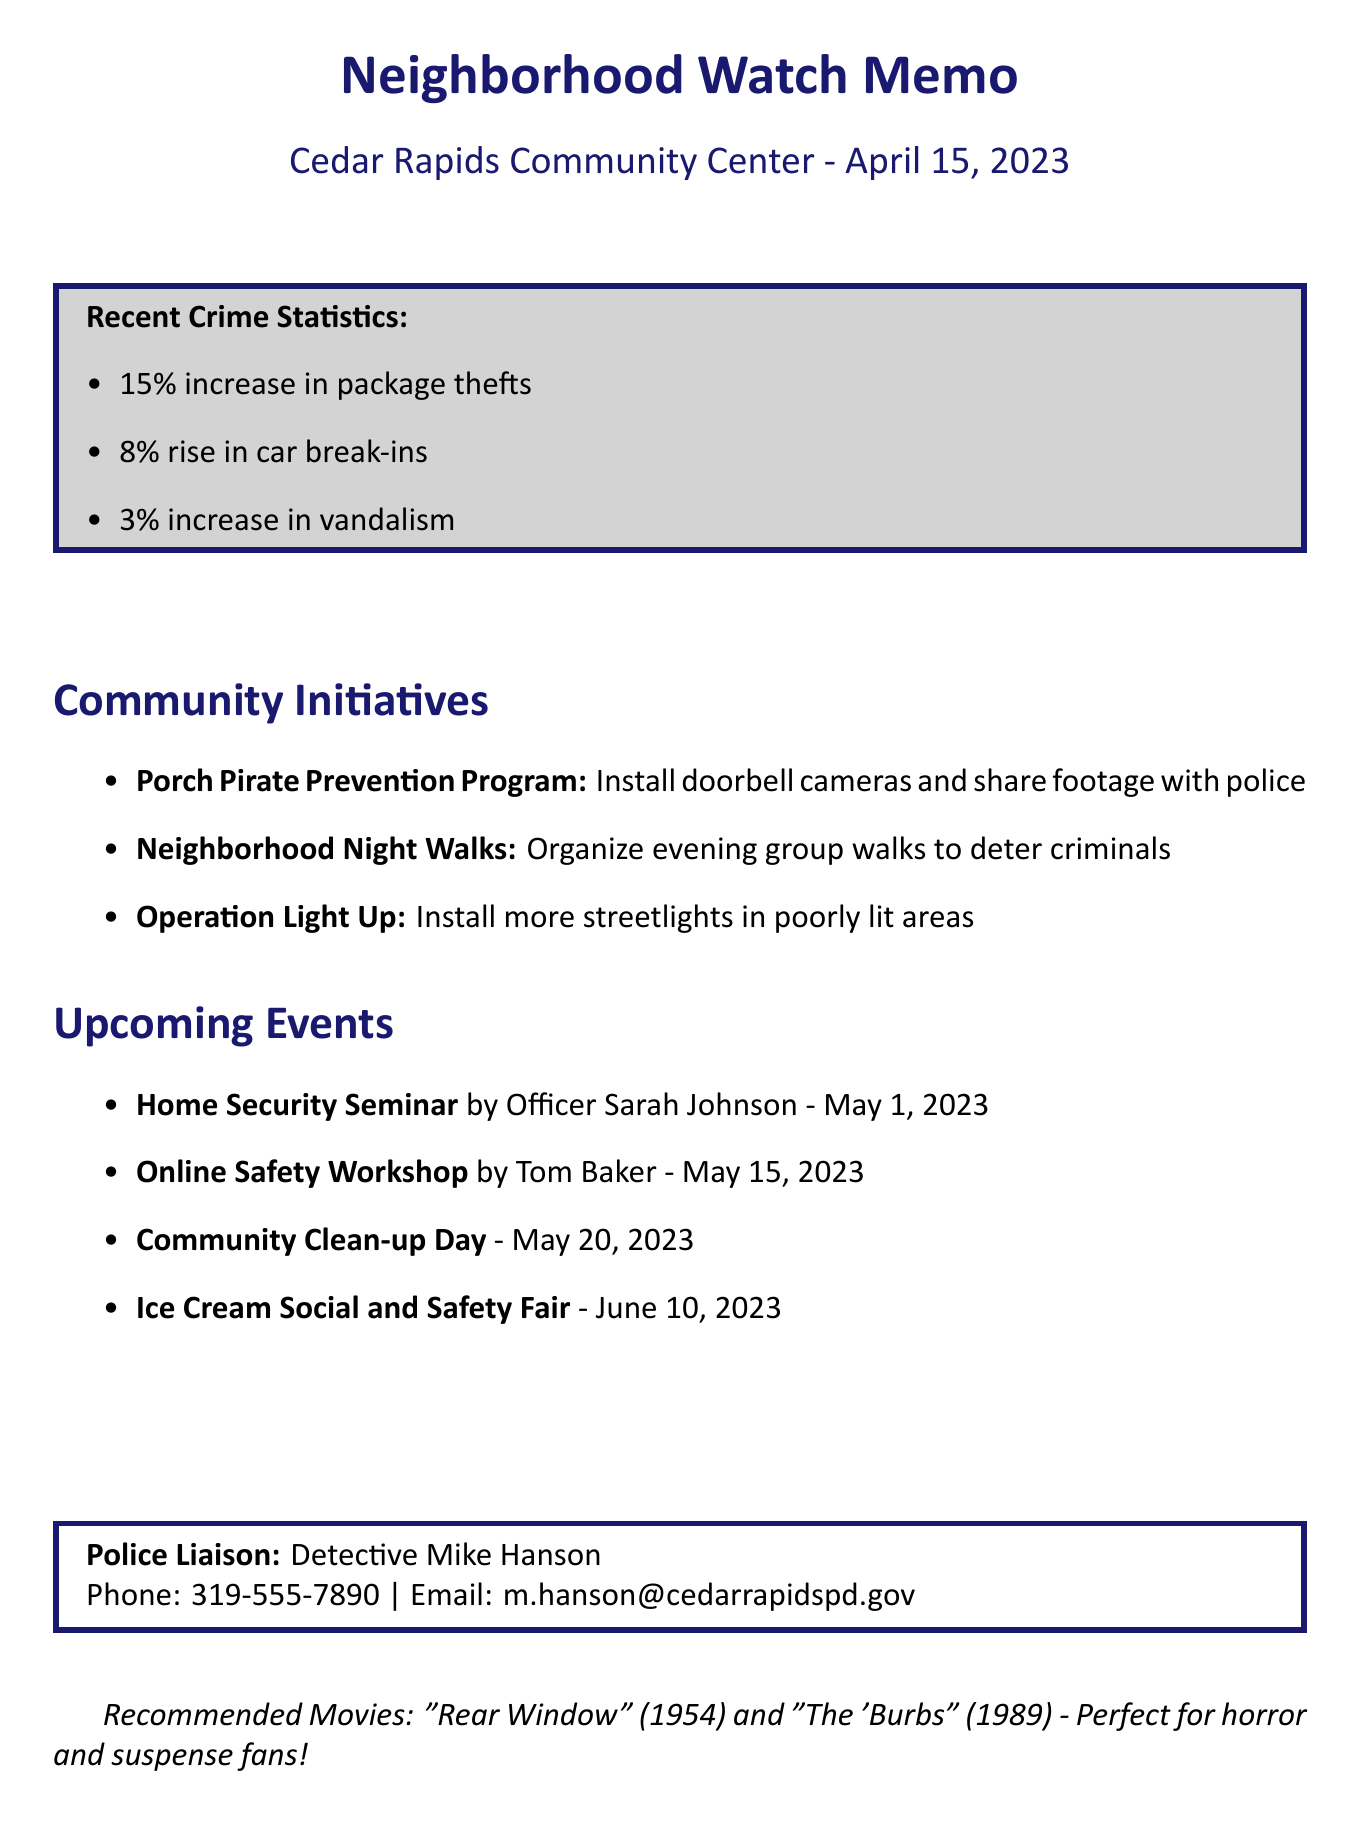What is the date of the neighborhood watch meeting? The date of the meeting is explicitly mentioned in the document as April 15, 2023.
Answer: April 15, 2023 How many attendees were present at the meeting? The document states that there were 32 attendees at the meeting.
Answer: 32 What initiative encourages residents to install doorbell cameras? The initiative encouraging the installation of doorbell cameras is specifically named in the document.
Answer: Porch Pirate Prevention Program Who is presenting the Home Security Seminar? The document provides the name of the presenter for the Home Security Seminar, which requires identifying the person mentioned.
Answer: Officer Sarah Johnson What percentage increase is reported for car break-ins? The document lists a specific percentage increase for car break-ins that needs to be recalled.
Answer: 8% What action was proposed to improve communication among neighbors? The document mentions a proposed solution to enhance communication amongst neighbors, which needs to be recalled.
Answer: Creation of a neighborhood watch Facebook group What is the name of the police liaison? The document specifies the name of the police liaison for the neighborhood watch group.
Answer: Detective Mike Hanson When is the Community Clean-up Day scheduled? The date for the Community Clean-up Day is provided in the document as part of upcoming events that needs to be recalled.
Answer: May 20, 2023 What is included in the document's recommended movies? The document lists specific movies recommended for fans of horror and suspense, which needs to be recalled.
Answer: Rear Window and The 'Burbs 